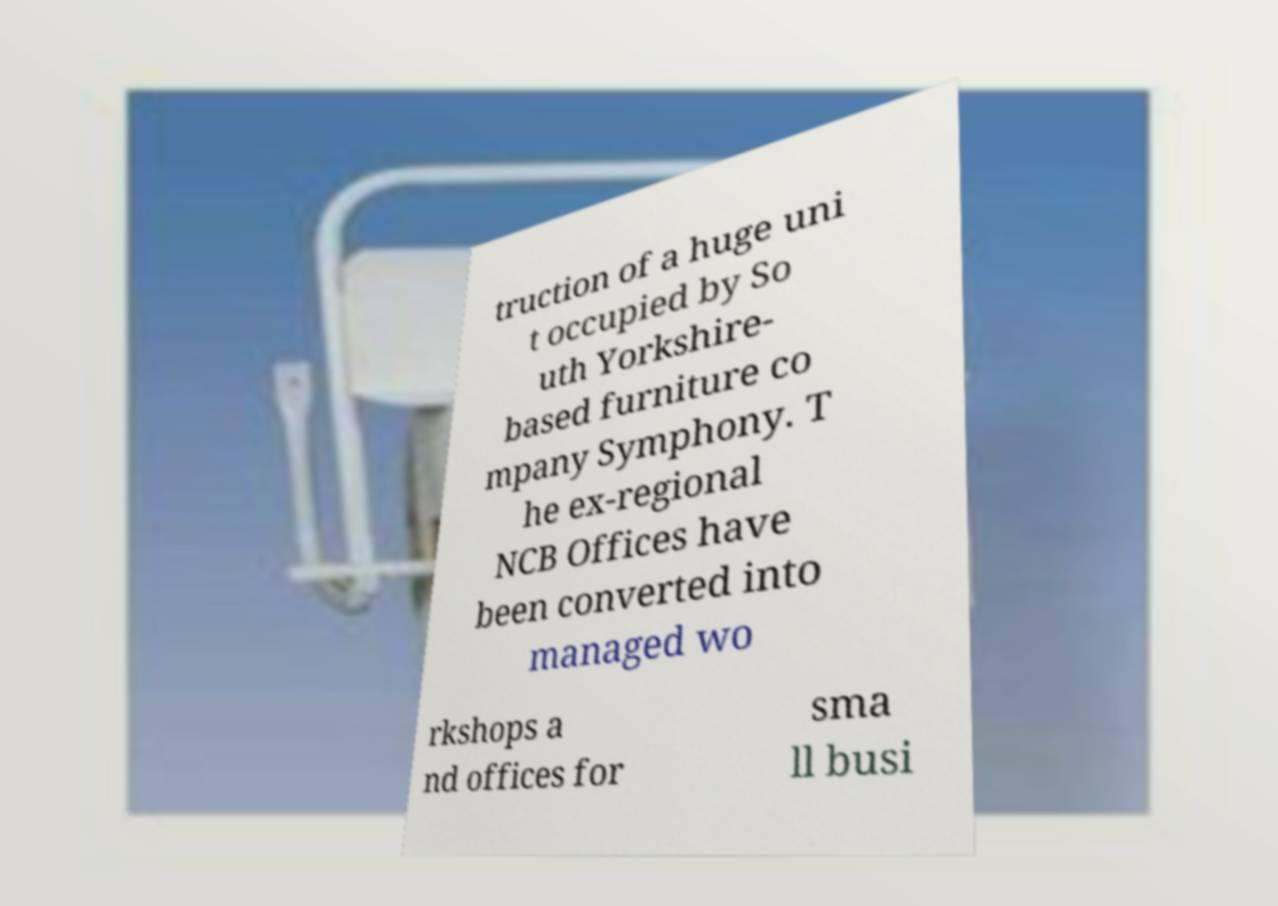I need the written content from this picture converted into text. Can you do that? truction of a huge uni t occupied by So uth Yorkshire- based furniture co mpany Symphony. T he ex-regional NCB Offices have been converted into managed wo rkshops a nd offices for sma ll busi 